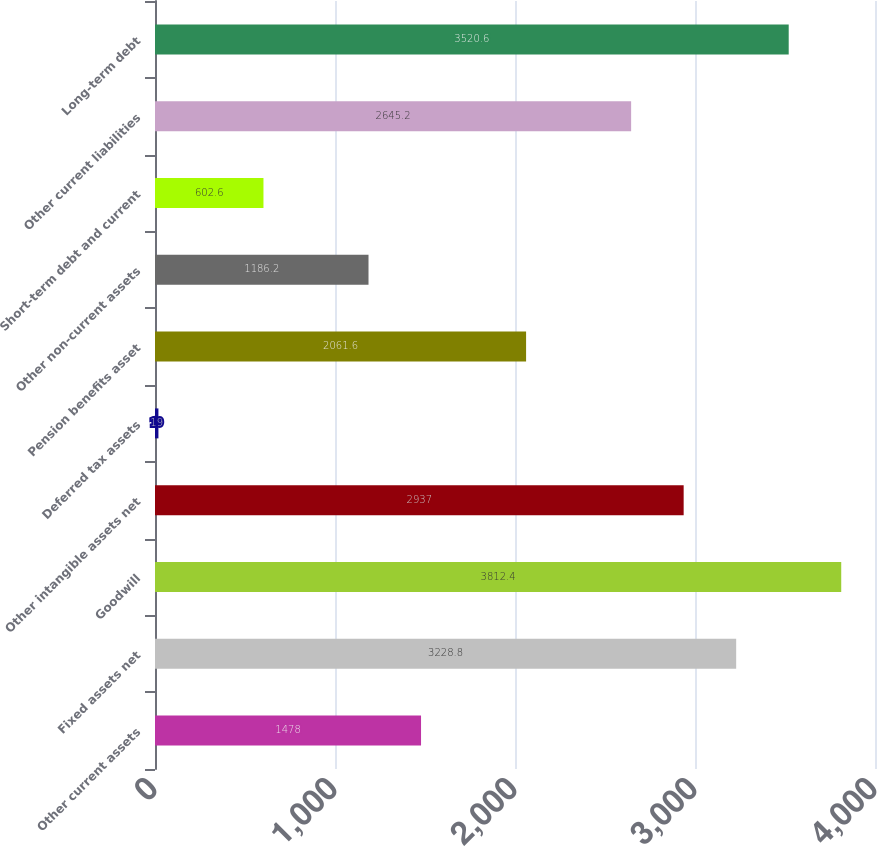Convert chart. <chart><loc_0><loc_0><loc_500><loc_500><bar_chart><fcel>Other current assets<fcel>Fixed assets net<fcel>Goodwill<fcel>Other intangible assets net<fcel>Deferred tax assets<fcel>Pension benefits asset<fcel>Other non-current assets<fcel>Short-term debt and current<fcel>Other current liabilities<fcel>Long-term debt<nl><fcel>1478<fcel>3228.8<fcel>3812.4<fcel>2937<fcel>19<fcel>2061.6<fcel>1186.2<fcel>602.6<fcel>2645.2<fcel>3520.6<nl></chart> 